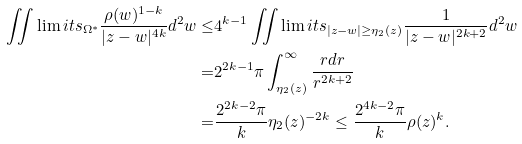Convert formula to latex. <formula><loc_0><loc_0><loc_500><loc_500>\iint \lim i t s _ { \Omega ^ { * } } \frac { \rho ( w ) ^ { 1 - k } } { | z - w | ^ { 4 k } } d ^ { 2 } w \leq & 4 ^ { k - 1 } \iint \lim i t s _ { | z - w | \geq \eta _ { 2 } ( z ) } \frac { 1 } { | z - w | ^ { 2 k + 2 } } d ^ { 2 } w \\ = & 2 ^ { 2 k - 1 } \pi \int _ { \eta _ { 2 } ( z ) } ^ { \infty } \frac { r d r } { r ^ { 2 k + 2 } } \\ = & \frac { 2 ^ { 2 k - 2 } \pi } { k } \eta _ { 2 } ( z ) ^ { - 2 k } \leq \frac { 2 ^ { 4 k - 2 } \pi } { k } \rho ( z ) ^ { k } .</formula> 